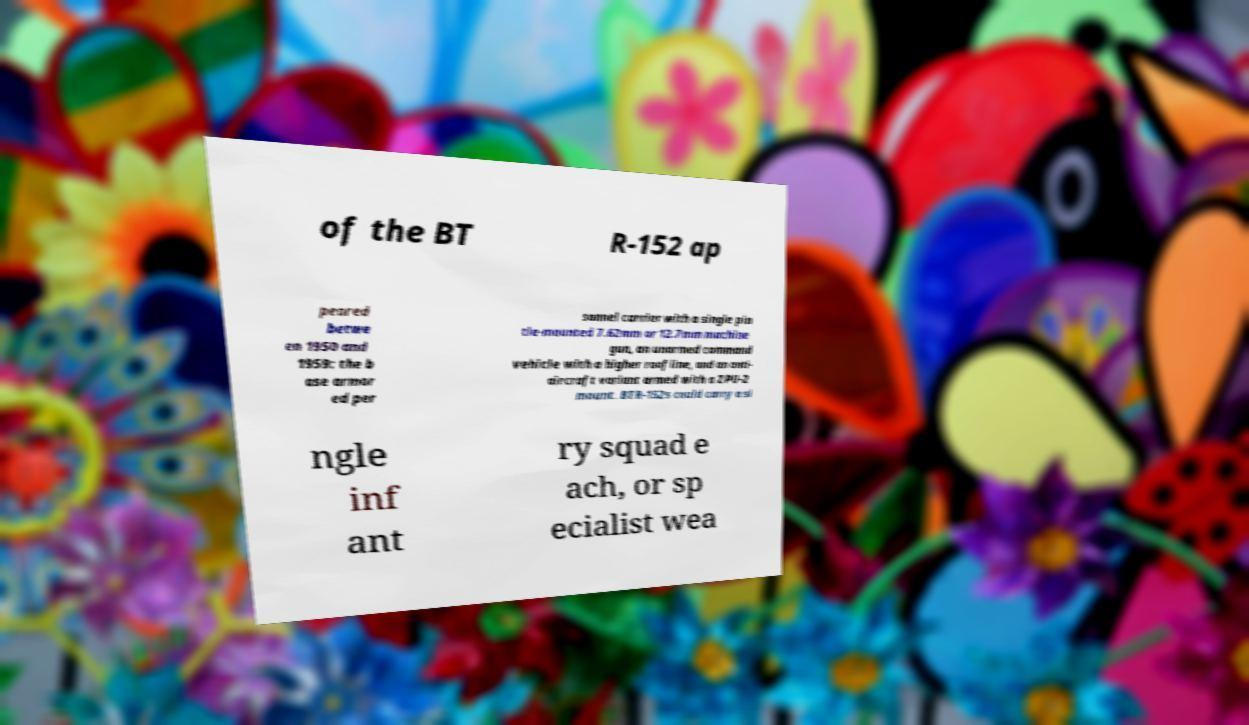Can you read and provide the text displayed in the image?This photo seems to have some interesting text. Can you extract and type it out for me? of the BT R-152 ap peared betwe en 1950 and 1959: the b ase armor ed per sonnel carrier with a single pin tle-mounted 7.62mm or 12.7mm machine gun, an unarmed command vehicle with a higher roofline, and an anti- aircraft variant armed with a ZPU-2 mount. BTR-152s could carry a si ngle inf ant ry squad e ach, or sp ecialist wea 